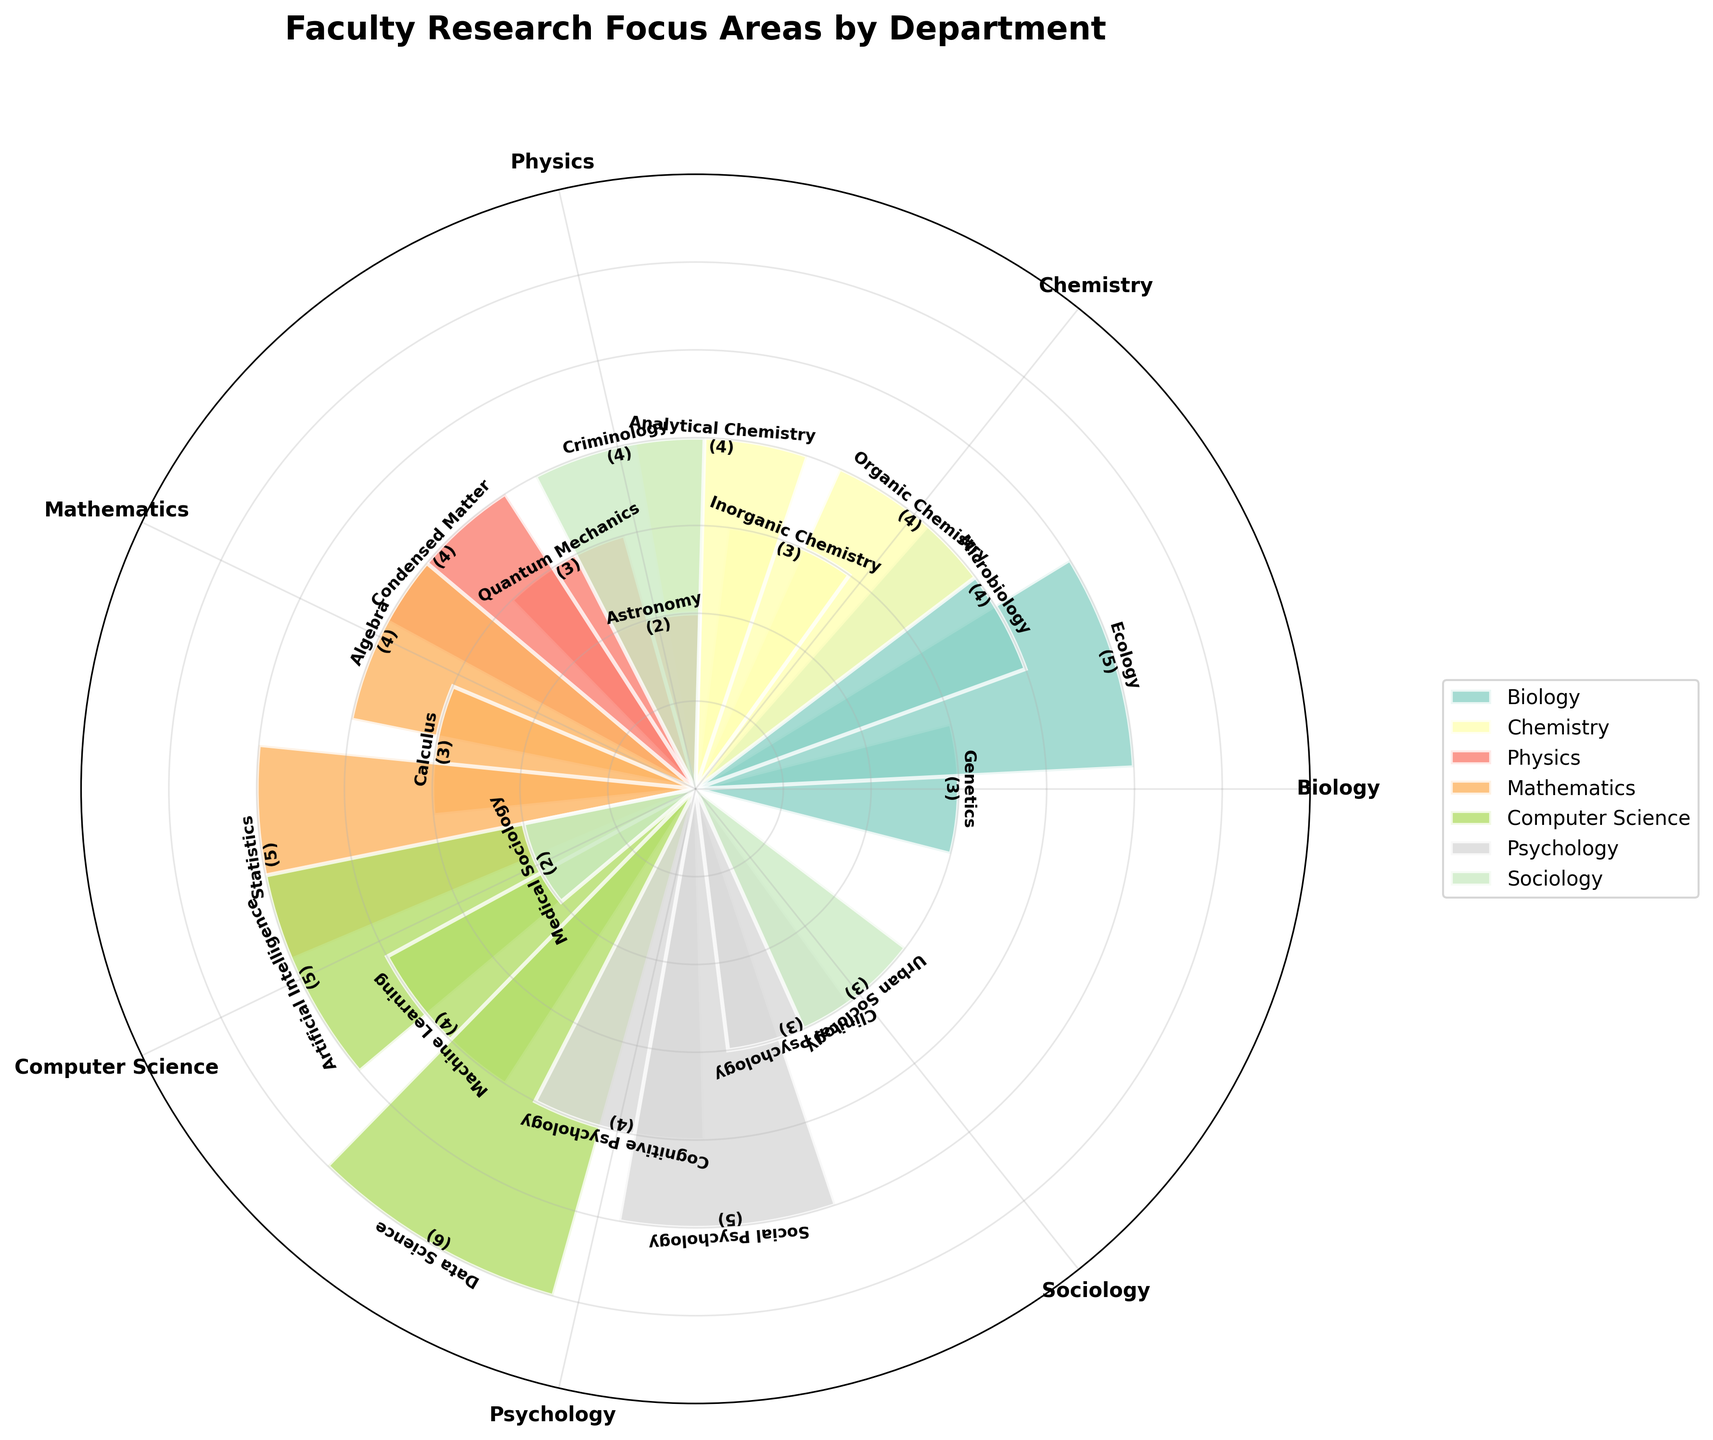What is the total number of research focus areas for the Biology department? The figure shows three categories for the Biology department: Genetics, Ecology, and Microbiology. Summing up their counts results in 3 + 5 + 4.
Answer: 12 Which department has the highest research focus area count in a single category? By examining the bars in the chart, we see the Computer Science department has the highest tallied area with Data Science at a count of 6.
Answer: Computer Science How many research focus areas does the Physics department have? The Physics department includes Astronomy, Quantum Mechanics, and Condensed Matter. Counting these categories gives us a total of three focus areas.
Answer: 3 What are the names and counts of the research focus areas in the Psychology department? From the chart, the Psychology department has three research focus areas: Cognitive Psychology with 4, Social Psychology with 5, and Clinical Psychology with 3.
Answer: Cognitive Psychology (4), Social Psychology (5), Clinical Psychology (3) Which focus area in the Mathematics department has the highest count and what is that count? In the Mathematics department, the area of Statistics has the highest bar with a count of 5.
Answer: Statistics (5) Compare the total research focus counts between the Chemistry and Sociology departments. Which is higher? The Chemistry department has Organic Chemistry (4), Inorganic Chemistry (3), and Analytical Chemistry (4), totaling 11. The Sociology department includes Urban Sociology (3), Medical Sociology (2), and Criminology (4), adding up to 9. Chemistry has the higher total count.
Answer: Chemistry What is the average count of research focus areas in the Computer Science department? The Computer Science department has Artificial Intelligence (5), Machine Learning (4), and Data Science (6). The average of these counts is (5 + 4 + 6) / 3 = 15 / 3 = 5.
Answer: 5 Which research focus area in Biology has the lowest count, and what is the count? According to the chart, Genetics in the Biology department has the lowest count with a value of 3.
Answer: Genetics (3) Between the focus areas in Quantum Mechanics and Urban Sociology, which one has a higher count? Quantum Mechanics has a count of 3, and Urban Sociology also has 3. Therefore, the counts are equal.
Answer: They are equal (3) What is the sum of counts for all research focus areas in the Psychology and Sociology departments combined? Summing all counts in Psychology (4, 5, 3) results in 12, and for Sociology (3, 2, 4) results in 9. The combined total is 12 + 9.
Answer: 21 